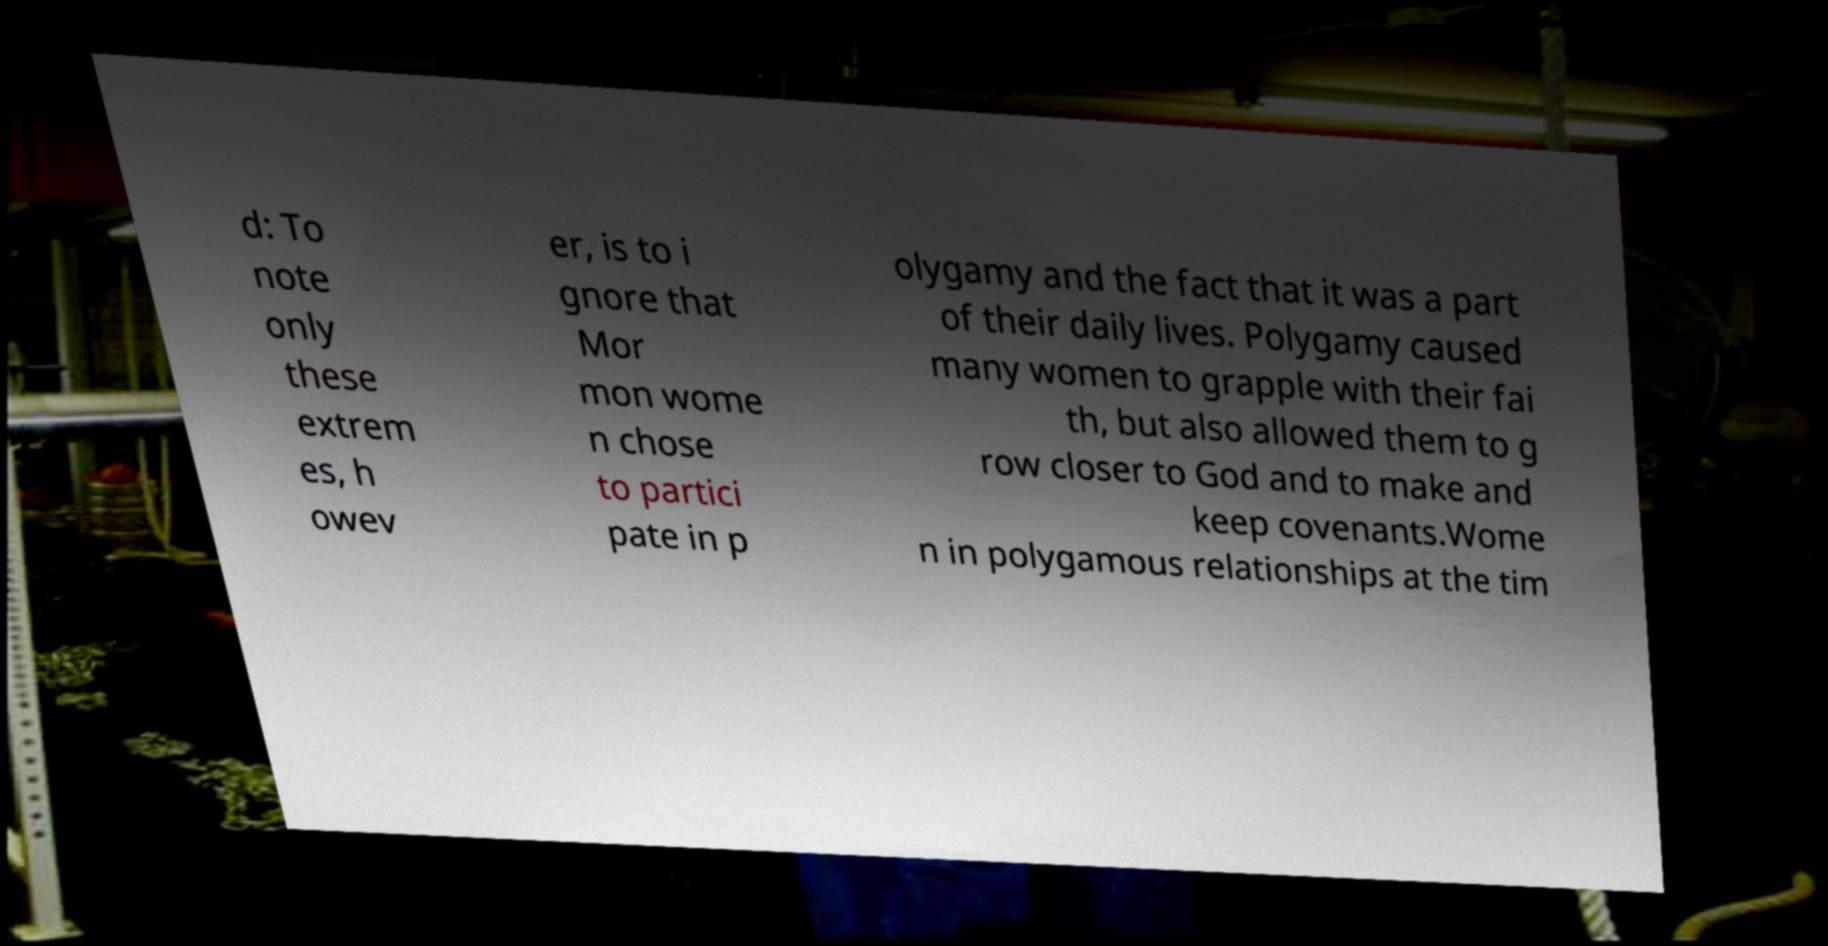I need the written content from this picture converted into text. Can you do that? d: To note only these extrem es, h owev er, is to i gnore that Mor mon wome n chose to partici pate in p olygamy and the fact that it was a part of their daily lives. Polygamy caused many women to grapple with their fai th, but also allowed them to g row closer to God and to make and keep covenants.Wome n in polygamous relationships at the tim 